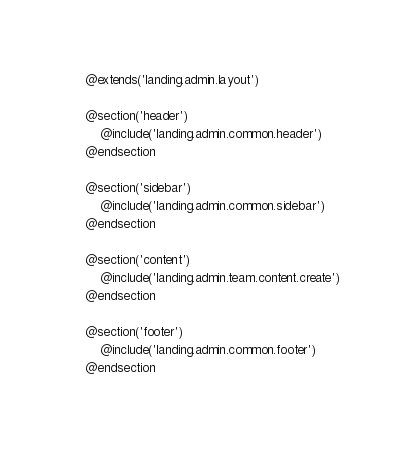Convert code to text. <code><loc_0><loc_0><loc_500><loc_500><_PHP_>@extends('landing.admin.layout')

@section('header')
    @include('landing.admin.common.header')
@endsection

@section('sidebar')
    @include('landing.admin.common.sidebar')
@endsection

@section('content')
    @include('landing.admin.team.content.create')
@endsection

@section('footer')
    @include('landing.admin.common.footer')
@endsection
</code> 